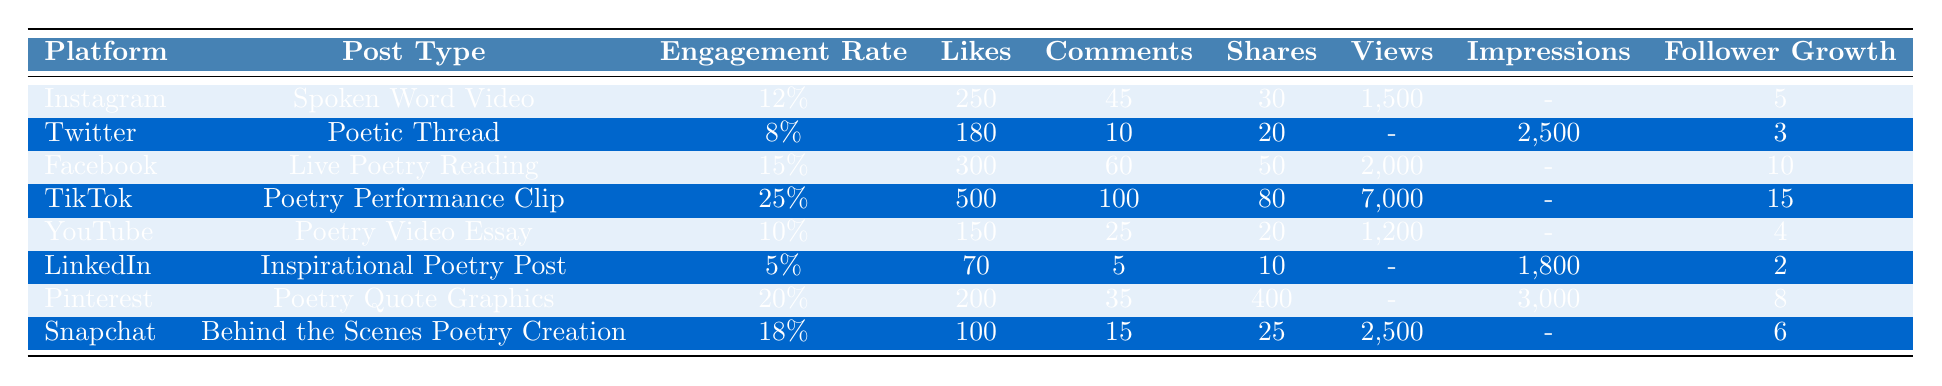What is the engagement rate for TikTok poetry posts? The table shows that the engagement rate for TikTok poetry posts is listed directly under the 'Engagement Rate' column for TikTok, which is 25%.
Answer: 25% Which platform had the highest number of likes for poetry posts? By checking the 'Likes' column, TikTok has the highest likes counted at 500.
Answer: TikTok How many comments did the Facebook Live Poetry Reading receive? The table indicates that Facebook received 60 comments for the Live Poetry Reading.
Answer: 60 What is the total number of shares across all platforms? To find the total shares, we need to add the shares from each platform: 30 (Instagram) + 20 (Twitter) + 50 (Facebook) + 80 (TikTok) + 20 (YouTube) + 10 (LinkedIn) + 400 (Pinterest) + 25 (Snapchat) = 635 shares total.
Answer: 635 Does the Pinterest Poetry Quote Graphics post have more likes than the LinkedIn Inspirational Poetry Post? By comparing the 'Likes' column, Pinterest has 200 likes, while LinkedIn only has 70, therefore Pinterest has more likes.
Answer: Yes Which post type had the lowest engagement rate? The engagement rate values are compared: Instagram (12%), Twitter (8%), Facebook (15%), TikTok (25%), YouTube (10%), LinkedIn (5%), Pinterest (20%), and Snapchat (18%). LinkedIn has the lowest engagement rate at 5%.
Answer: Inspirational Poetry Post on LinkedIn What is the average engagement rate of the poetry posts across all platforms? Calculate the average by summing up the engagement rates (0.12 + 0.08 + 0.15 + 0.25 + 0.10 + 0.05 + 0.20 + 0.18 = 1.13) then divide by the number of platforms (8). Thus, the average engagement rate is 1.13/8 = 0.14125 or approximately 14.13%.
Answer: 14.13% Which platform has the highest follower growth? Looking at the 'Follower Growth' column, TikTok shows the highest growth at 15 followers gained.
Answer: TikTok Is the engagement rate of Facebook's Live Poetry Reading higher than that of the Poetry Video Essay on YouTube? Facebook's engagement rate is 15%, while YouTube's is 10%. Since 15% is greater than 10%, the statement is true.
Answer: Yes What is the views to likes ratio for TikTok's Poetry Performance Clip? For TikTok, likes are 500 and views are 7000. The ratio is calculated as views/likes: 7000/500 = 14.
Answer: 14 